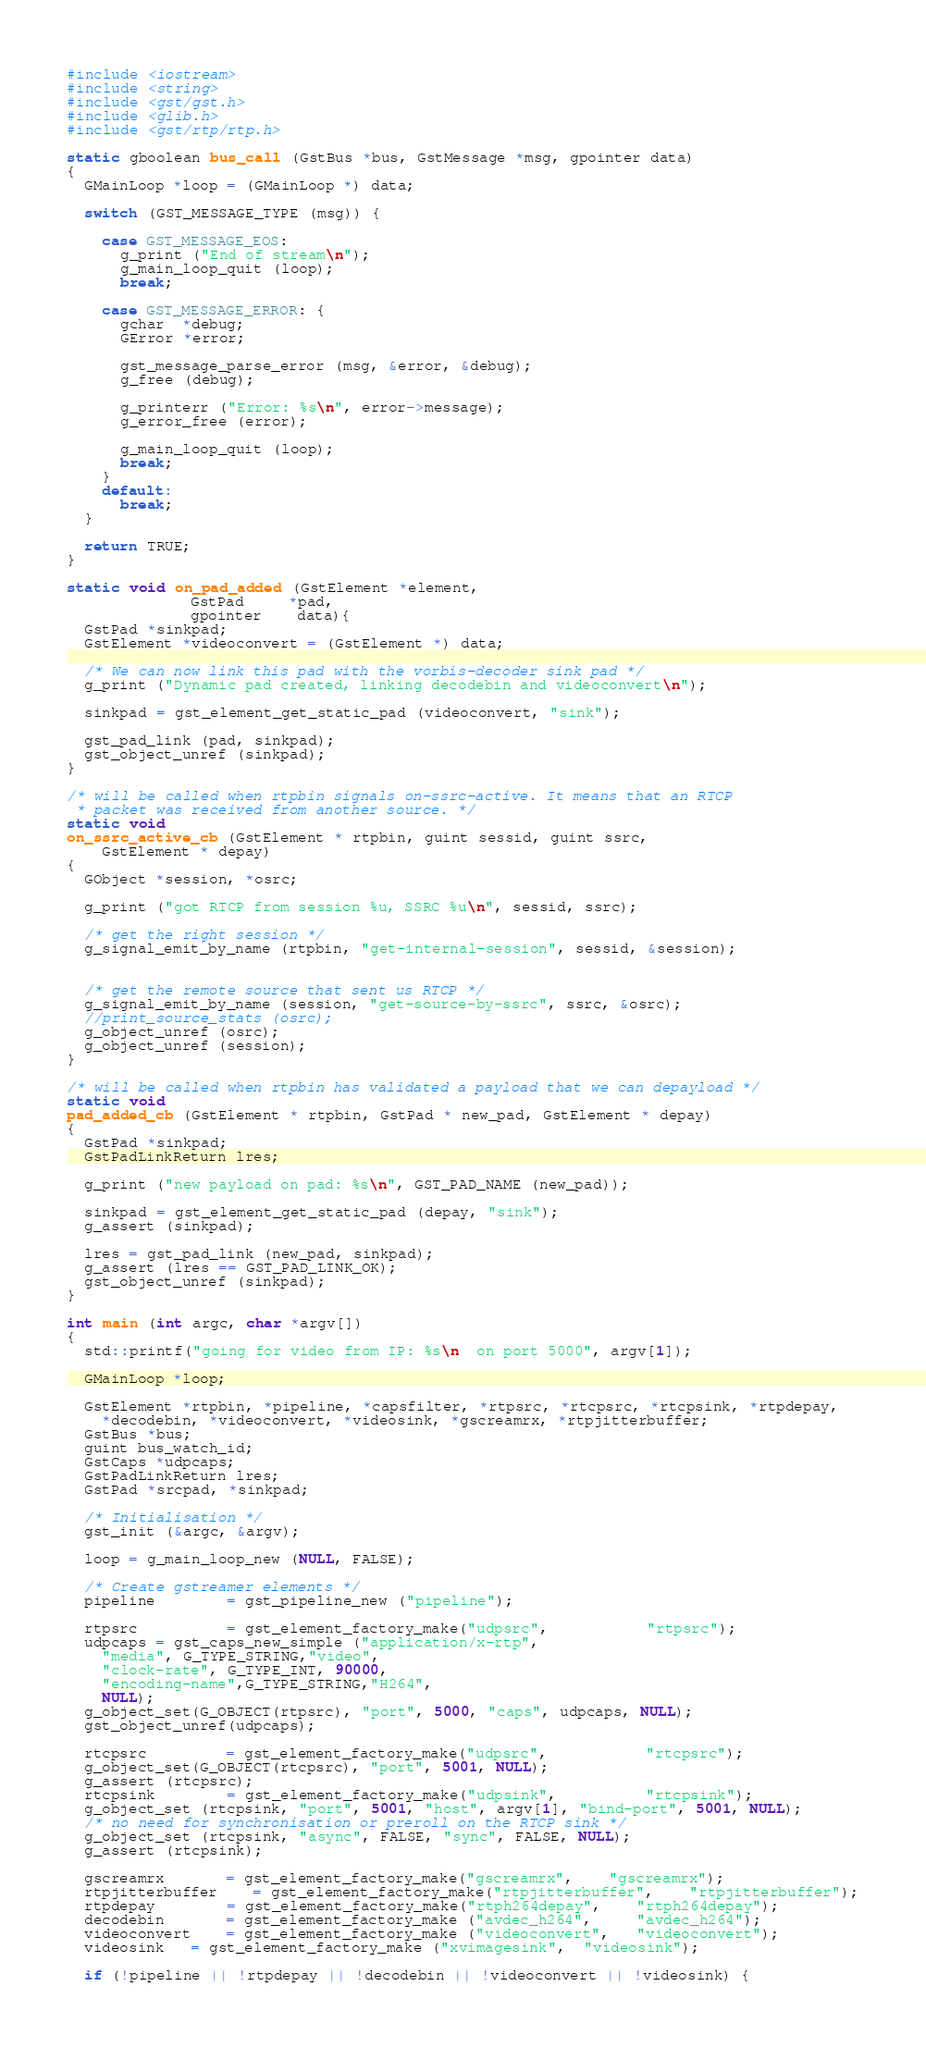<code> <loc_0><loc_0><loc_500><loc_500><_C++_>#include <iostream>
#include <string>
#include <gst/gst.h>
#include <glib.h>
#include <gst/rtp/rtp.h>

static gboolean bus_call (GstBus *bus, GstMessage *msg, gpointer data)
{
  GMainLoop *loop = (GMainLoop *) data;

  switch (GST_MESSAGE_TYPE (msg)) {

    case GST_MESSAGE_EOS:
      g_print ("End of stream\n");
      g_main_loop_quit (loop);
      break;

    case GST_MESSAGE_ERROR: {
      gchar  *debug;
      GError *error;

      gst_message_parse_error (msg, &error, &debug);
      g_free (debug);

      g_printerr ("Error: %s\n", error->message);
      g_error_free (error);

      g_main_loop_quit (loop);
      break;
    }
    default:
      break;
  }

  return TRUE;
}

static void on_pad_added (GstElement *element,
              GstPad     *pad,
              gpointer    data){
  GstPad *sinkpad;
  GstElement *videoconvert = (GstElement *) data;

  /* We can now link this pad with the vorbis-decoder sink pad */
  g_print ("Dynamic pad created, linking decodebin and videoconvert\n");

  sinkpad = gst_element_get_static_pad (videoconvert, "sink");

  gst_pad_link (pad, sinkpad);
  gst_object_unref (sinkpad);
}

/* will be called when rtpbin signals on-ssrc-active. It means that an RTCP
 * packet was received from another source. */
static void
on_ssrc_active_cb (GstElement * rtpbin, guint sessid, guint ssrc,
    GstElement * depay)
{
  GObject *session, *osrc;

  g_print ("got RTCP from session %u, SSRC %u\n", sessid, ssrc);

  /* get the right session */
  g_signal_emit_by_name (rtpbin, "get-internal-session", sessid, &session);


  /* get the remote source that sent us RTCP */
  g_signal_emit_by_name (session, "get-source-by-ssrc", ssrc, &osrc);
  //print_source_stats (osrc);
  g_object_unref (osrc);
  g_object_unref (session);
}

/* will be called when rtpbin has validated a payload that we can depayload */
static void
pad_added_cb (GstElement * rtpbin, GstPad * new_pad, GstElement * depay)
{
  GstPad *sinkpad;
  GstPadLinkReturn lres;

  g_print ("new payload on pad: %s\n", GST_PAD_NAME (new_pad));

  sinkpad = gst_element_get_static_pad (depay, "sink");
  g_assert (sinkpad);

  lres = gst_pad_link (new_pad, sinkpad);
  g_assert (lres == GST_PAD_LINK_OK);
  gst_object_unref (sinkpad);
}

int main (int argc, char *argv[])
{
  std::printf("going for video from IP: %s\n  on port 5000", argv[1]);

  GMainLoop *loop;

  GstElement *rtpbin, *pipeline, *capsfilter, *rtpsrc, *rtcpsrc, *rtcpsink, *rtpdepay,
    *decodebin, *videoconvert, *videosink, *gscreamrx, *rtpjitterbuffer;
  GstBus *bus;
  guint bus_watch_id;
  GstCaps *udpcaps;
  GstPadLinkReturn lres;
  GstPad *srcpad, *sinkpad;

  /* Initialisation */
  gst_init (&argc, &argv);

  loop = g_main_loop_new (NULL, FALSE);

  /* Create gstreamer elements */
  pipeline        = gst_pipeline_new ("pipeline");

  rtpsrc          = gst_element_factory_make("udpsrc",           "rtpsrc");
  udpcaps = gst_caps_new_simple ("application/x-rtp",
    "media", G_TYPE_STRING,"video",
    "clock-rate", G_TYPE_INT, 90000,
    "encoding-name",G_TYPE_STRING,"H264",
    NULL);
  g_object_set(G_OBJECT(rtpsrc), "port", 5000, "caps", udpcaps, NULL);
  gst_object_unref(udpcaps);

  rtcpsrc         = gst_element_factory_make("udpsrc",           "rtcpsrc");
  g_object_set(G_OBJECT(rtcpsrc), "port", 5001, NULL);
  g_assert (rtcpsrc);
  rtcpsink        = gst_element_factory_make("udpsink",          "rtcpsink");
  g_object_set (rtcpsink, "port", 5001, "host", argv[1], "bind-port", 5001, NULL);
  /* no need for synchronisation or preroll on the RTCP sink */
  g_object_set (rtcpsink, "async", FALSE, "sync", FALSE, NULL);
  g_assert (rtcpsink);

  gscreamrx       = gst_element_factory_make("gscreamrx",    "gscreamrx");
  rtpjitterbuffer    = gst_element_factory_make("rtpjitterbuffer",    "rtpjitterbuffer");
  rtpdepay        = gst_element_factory_make("rtph264depay",    "rtph264depay");
  decodebin       = gst_element_factory_make ("avdec_h264",     "avdec_h264");
  videoconvert    = gst_element_factory_make ("videoconvert",   "videoconvert");
  videosink   = gst_element_factory_make ("xvimagesink",  "videosink");

  if (!pipeline || !rtpdepay || !decodebin || !videoconvert || !videosink) {</code> 